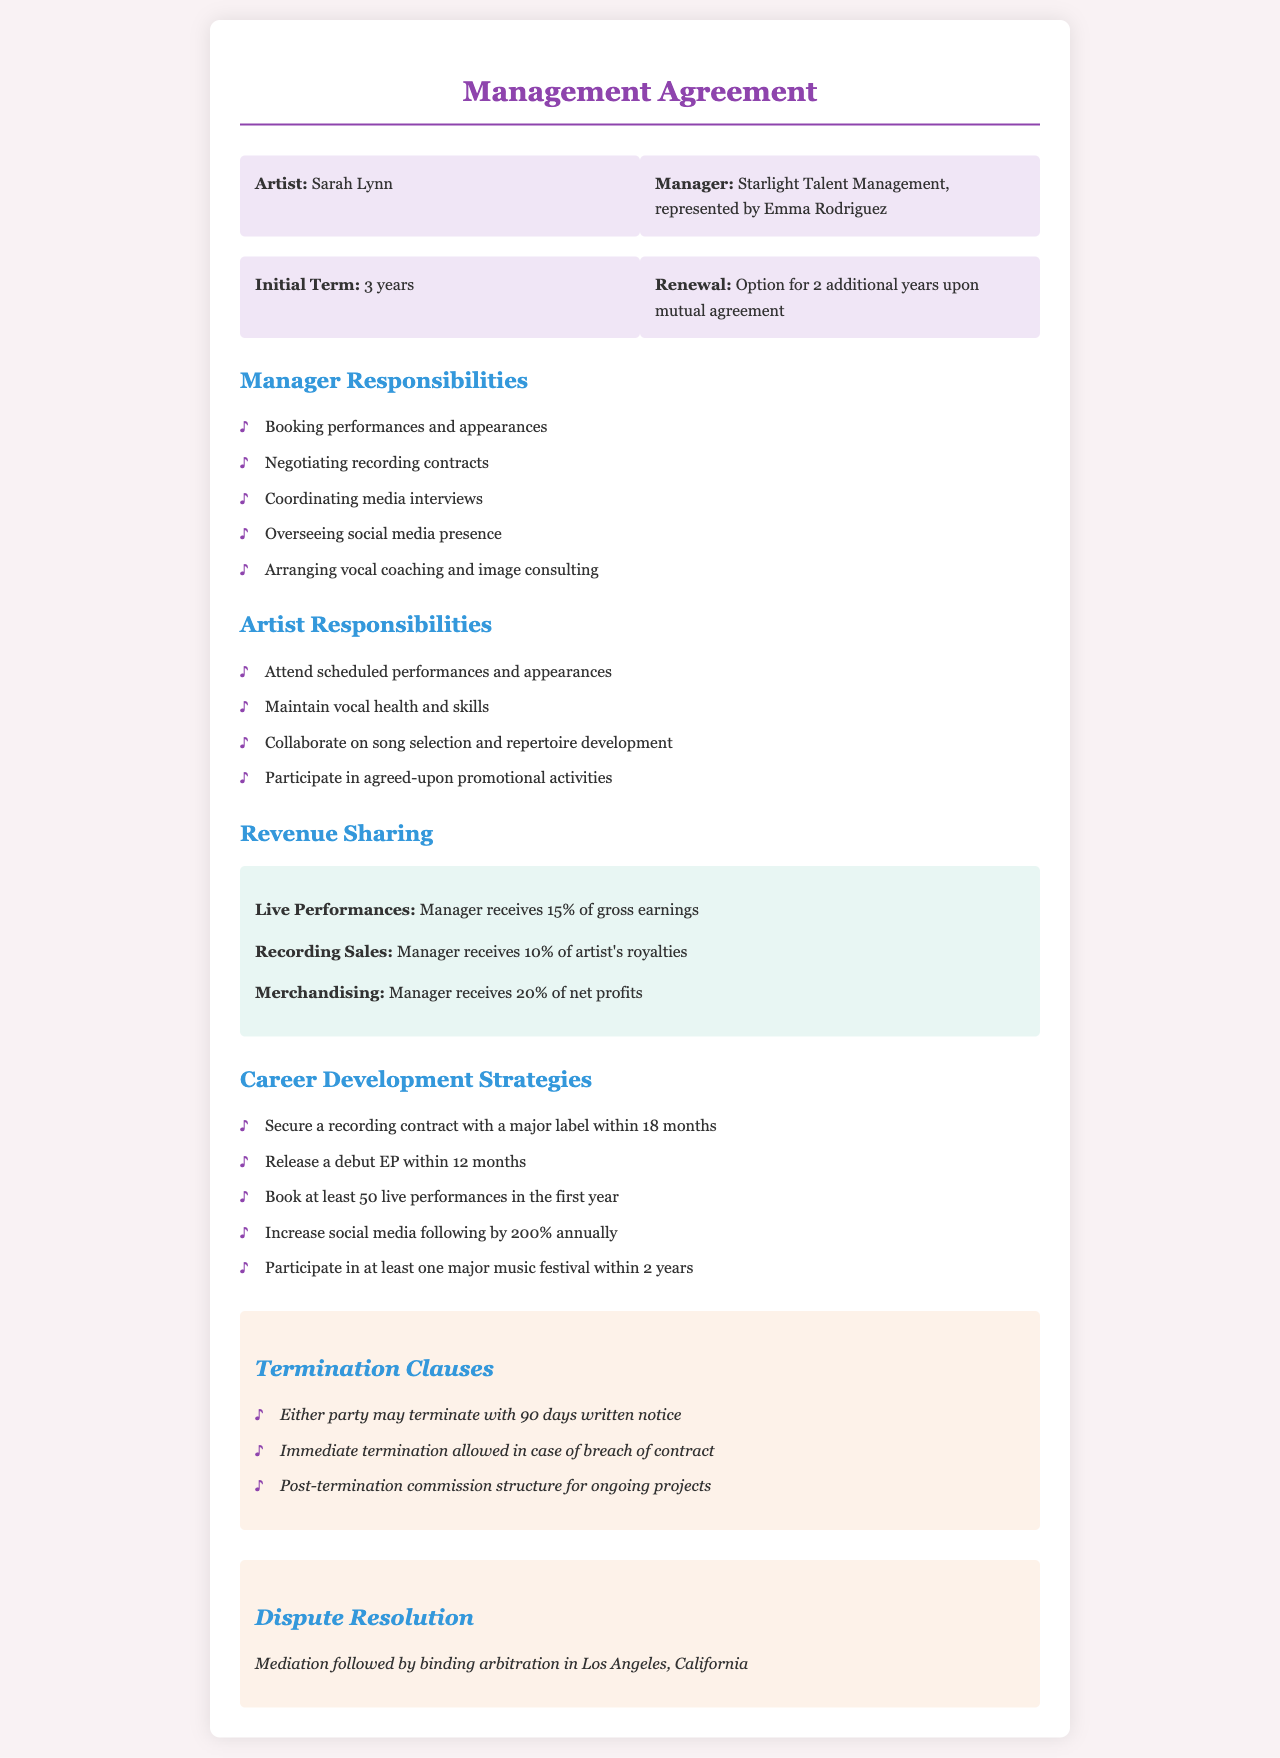What is the initial term of the management agreement? The initial term of the agreement is explicitly stated in the document as 3 years.
Answer: 3 years Who represents the management company? The document specifies that Emma Rodriguez represents Starlight Talent Management.
Answer: Emma Rodriguez What percentage does the manager receive from live performances? The gross earnings from live performances and the manager's share are detailed in the revenue sharing section as 15%.
Answer: 15% How many live performances should be booked in the first year? The career development strategies highlight the goal of booking at least 50 live performances in the first year.
Answer: 50 What is the revenue share percentage for merchandising? The document provides the percentage of net profits the manager receives from merchandising as 20%.
Answer: 20% What is allowed for immediate termination of the contract? The document mentions that immediate termination is allowed in the case of a breach of contract.
Answer: Breach of contract Where will disputes be resolved? The document clearly states that mediation followed by binding arbitration will take place in Los Angeles, California.
Answer: Los Angeles What is one of the career development strategies regarding social media? The strategy includes increasing social media following by a specific percentage annually, which is 200%.
Answer: 200% What is the total renewal option period stated in the agreement? The option for renewal upon mutual agreement mentions an additional period of 2 years.
Answer: 2 years 